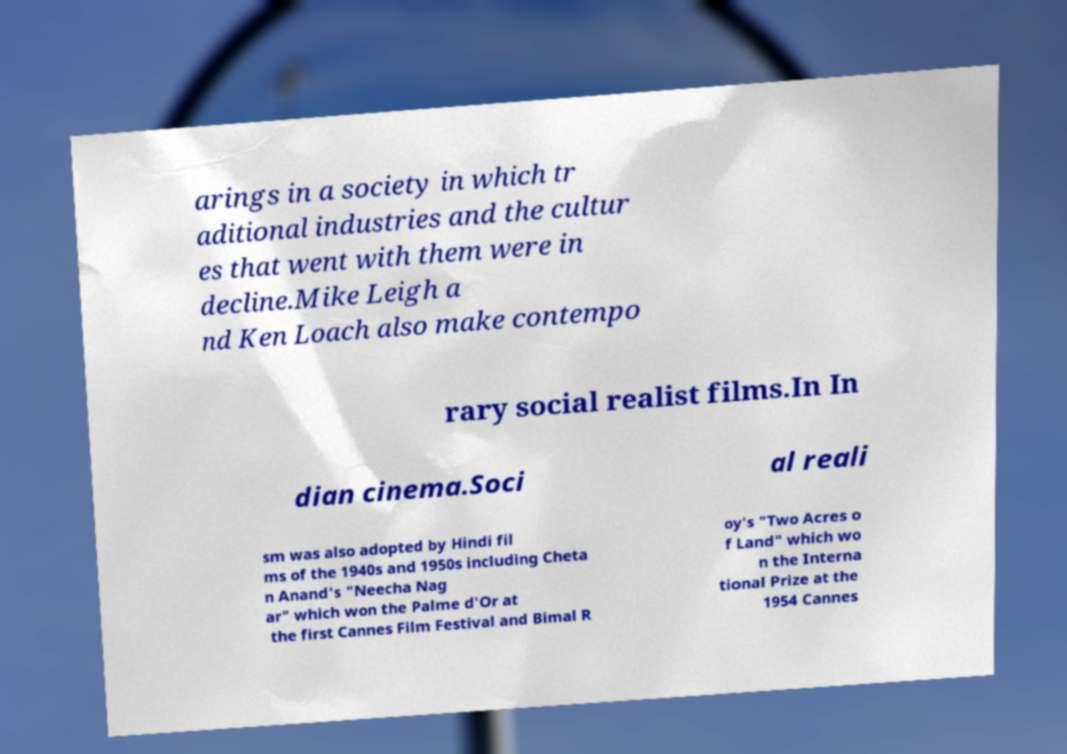Please read and relay the text visible in this image. What does it say? arings in a society in which tr aditional industries and the cultur es that went with them were in decline.Mike Leigh a nd Ken Loach also make contempo rary social realist films.In In dian cinema.Soci al reali sm was also adopted by Hindi fil ms of the 1940s and 1950s including Cheta n Anand's "Neecha Nag ar" which won the Palme d'Or at the first Cannes Film Festival and Bimal R oy's "Two Acres o f Land" which wo n the Interna tional Prize at the 1954 Cannes 